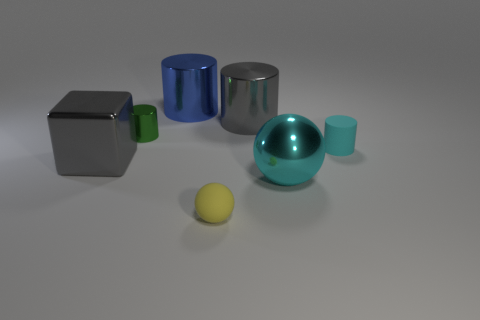There is a matte object that is to the left of the small thing to the right of the yellow matte thing; what color is it?
Your answer should be compact. Yellow. What number of other objects are there of the same color as the block?
Provide a succinct answer. 1. What number of objects are tiny green metallic cylinders or shiny things that are to the right of the large block?
Your response must be concise. 4. There is a metallic cylinder on the right side of the big blue metal object; what is its color?
Your answer should be compact. Gray. The green object is what shape?
Provide a succinct answer. Cylinder. The large cylinder left of the gray object that is behind the large gray metallic cube is made of what material?
Keep it short and to the point. Metal. How many other things are the same material as the gray cylinder?
Ensure brevity in your answer.  4. There is a cylinder that is the same size as the cyan rubber thing; what material is it?
Keep it short and to the point. Metal. Are there more cyan metal balls that are behind the cube than yellow spheres that are to the right of the tiny yellow rubber object?
Your answer should be very brief. No. Is there another thing that has the same shape as the small yellow matte object?
Your answer should be compact. Yes. 